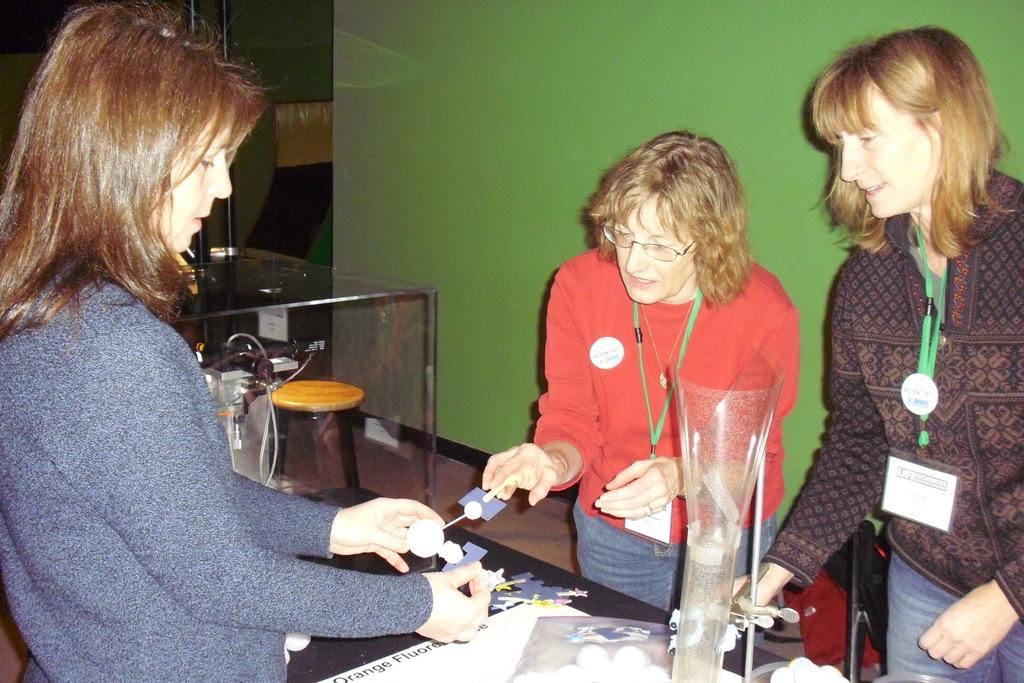What can be seen in the image besides the table? There are persons standing near the table. What is located in the background of the image? There is a chair and a wall in the background. What type of sail can be seen in the image? There is no sail present in the image. Is there a beggar visible in the image? There is no beggar present in the image. 